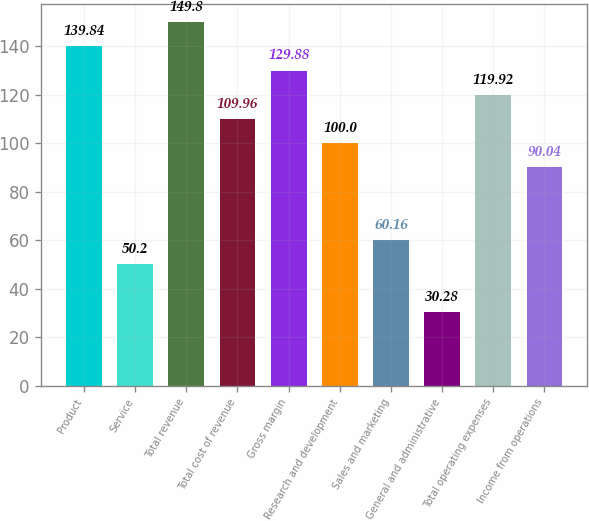Convert chart to OTSL. <chart><loc_0><loc_0><loc_500><loc_500><bar_chart><fcel>Product<fcel>Service<fcel>Total revenue<fcel>Total cost of revenue<fcel>Gross margin<fcel>Research and development<fcel>Sales and marketing<fcel>General and administrative<fcel>Total operating expenses<fcel>Income from operations<nl><fcel>139.84<fcel>50.2<fcel>149.8<fcel>109.96<fcel>129.88<fcel>100<fcel>60.16<fcel>30.28<fcel>119.92<fcel>90.04<nl></chart> 